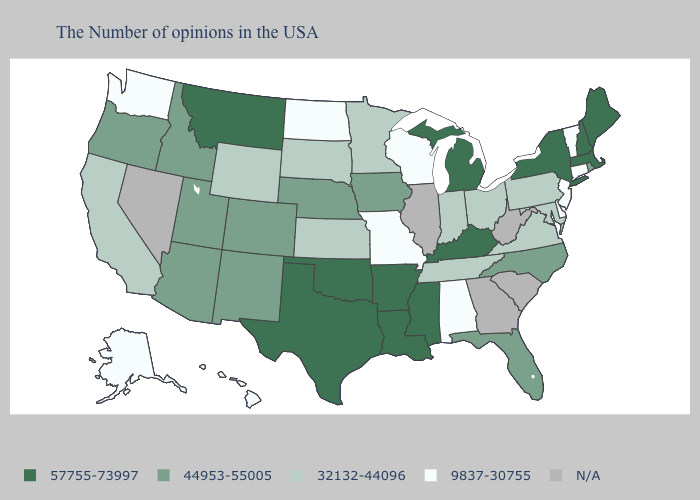Does the map have missing data?
Short answer required. Yes. What is the highest value in the Northeast ?
Keep it brief. 57755-73997. Which states have the highest value in the USA?
Write a very short answer. Maine, Massachusetts, New Hampshire, New York, Michigan, Kentucky, Mississippi, Louisiana, Arkansas, Oklahoma, Texas, Montana. Does Alaska have the lowest value in the USA?
Concise answer only. Yes. What is the value of New Hampshire?
Keep it brief. 57755-73997. Does Washington have the lowest value in the West?
Answer briefly. Yes. Among the states that border Massachusetts , does New Hampshire have the highest value?
Be succinct. Yes. Name the states that have a value in the range 44953-55005?
Write a very short answer. Rhode Island, North Carolina, Florida, Iowa, Nebraska, Colorado, New Mexico, Utah, Arizona, Idaho, Oregon. Name the states that have a value in the range 44953-55005?
Concise answer only. Rhode Island, North Carolina, Florida, Iowa, Nebraska, Colorado, New Mexico, Utah, Arizona, Idaho, Oregon. Name the states that have a value in the range 32132-44096?
Answer briefly. Maryland, Pennsylvania, Virginia, Ohio, Indiana, Tennessee, Minnesota, Kansas, South Dakota, Wyoming, California. Which states have the lowest value in the Northeast?
Quick response, please. Vermont, Connecticut, New Jersey. Name the states that have a value in the range 32132-44096?
Short answer required. Maryland, Pennsylvania, Virginia, Ohio, Indiana, Tennessee, Minnesota, Kansas, South Dakota, Wyoming, California. Which states have the lowest value in the MidWest?
Write a very short answer. Wisconsin, Missouri, North Dakota. What is the value of California?
Quick response, please. 32132-44096. What is the highest value in the USA?
Keep it brief. 57755-73997. 